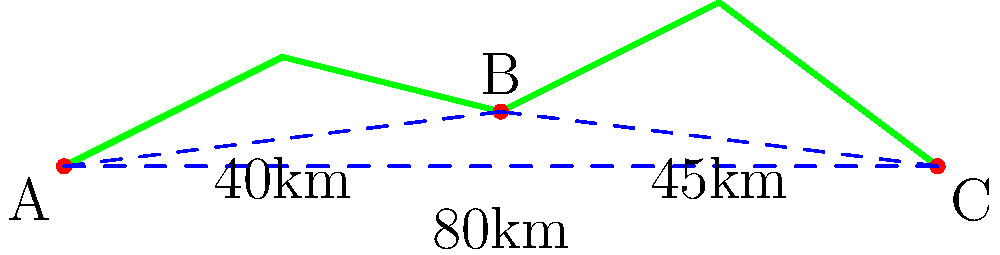Given the terrain map showing three military outposts A, B, and C, what is the shortest path to connect all three outposts? Provide the total distance of this path in kilometers. To find the shortest path connecting all three outposts, we need to compare the possible routes:

1. Path A-B-C:
   Distance A to B = 40 km
   Distance B to C = 45 km
   Total = 40 + 45 = 85 km

2. Path A-C (direct):
   Distance A to C = 80 km

3. Path A-B + A-C:
   Distance A to B = 40 km
   Distance A to C = 80 km
   Total = 40 + 80 = 120 km

4. Path B-C + B-A:
   Distance B to C = 45 km
   Distance B to A = 40 km
   Total = 45 + 40 = 85 km

The shortest path is either A-B-C or B-C-A, both with a total distance of 85 km. This path connects all three outposts using the two shorter segments (A-B and B-C) instead of the longer direct path between A and C.
Answer: A-B-C or B-C-A, 85 km 